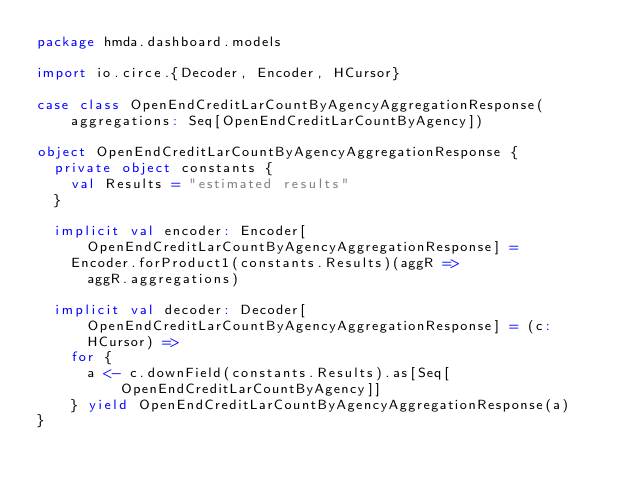Convert code to text. <code><loc_0><loc_0><loc_500><loc_500><_Scala_>package hmda.dashboard.models

import io.circe.{Decoder, Encoder, HCursor}

case class OpenEndCreditLarCountByAgencyAggregationResponse(aggregations: Seq[OpenEndCreditLarCountByAgency])

object OpenEndCreditLarCountByAgencyAggregationResponse {
  private object constants {
    val Results = "estimated results"
  }

  implicit val encoder: Encoder[OpenEndCreditLarCountByAgencyAggregationResponse] =
    Encoder.forProduct1(constants.Results)(aggR =>
      aggR.aggregations)

  implicit val decoder: Decoder[OpenEndCreditLarCountByAgencyAggregationResponse] = (c: HCursor) =>
    for {
      a <- c.downField(constants.Results).as[Seq[OpenEndCreditLarCountByAgency]]
    } yield OpenEndCreditLarCountByAgencyAggregationResponse(a)
}
</code> 